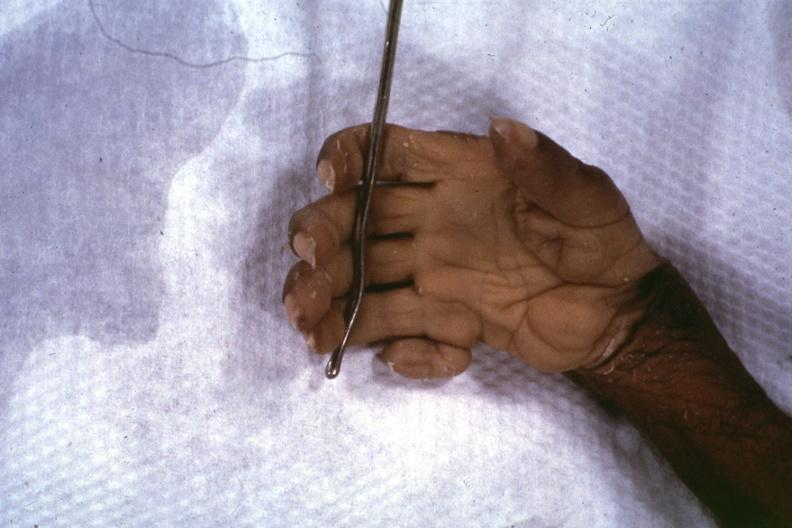what are present?
Answer the question using a single word or phrase. Extremities 